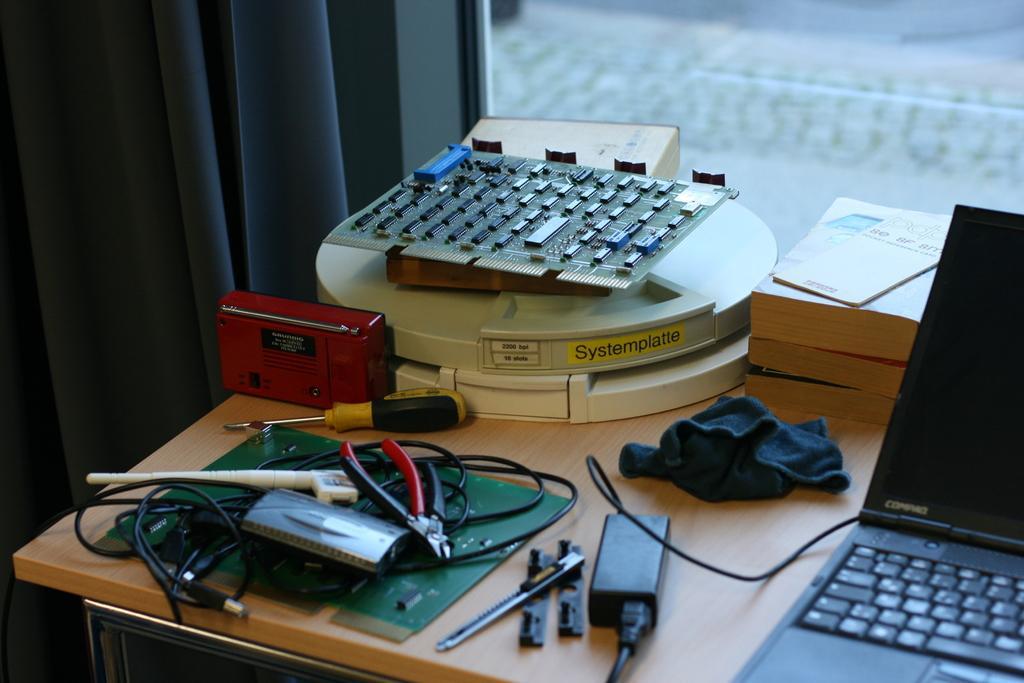Could you give a brief overview of what you see in this image? On the background we can see window and curtains. On the table we can see laptop, cloth, adapter, screwdriver, cutting plier and a red fm radio and some tools. This is a paper. 